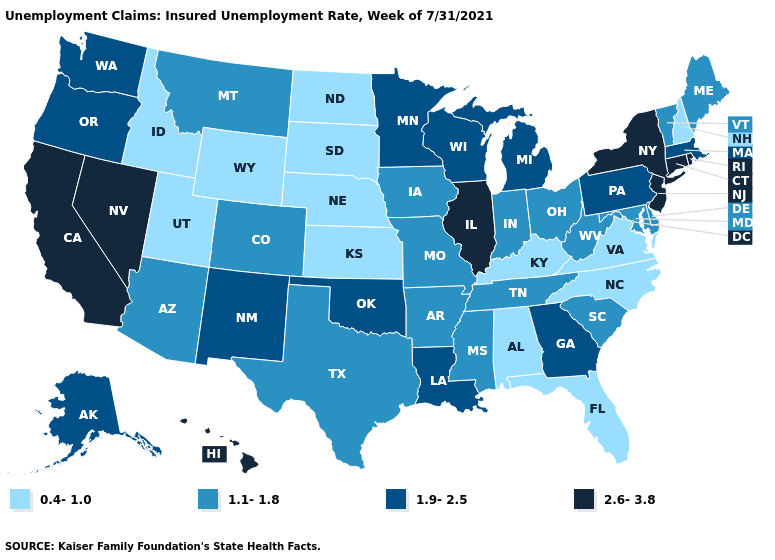What is the value of Alaska?
Concise answer only. 1.9-2.5. Among the states that border Nebraska , does Kansas have the highest value?
Quick response, please. No. Name the states that have a value in the range 2.6-3.8?
Give a very brief answer. California, Connecticut, Hawaii, Illinois, Nevada, New Jersey, New York, Rhode Island. What is the lowest value in the MidWest?
Be succinct. 0.4-1.0. What is the highest value in the USA?
Be succinct. 2.6-3.8. Name the states that have a value in the range 2.6-3.8?
Answer briefly. California, Connecticut, Hawaii, Illinois, Nevada, New Jersey, New York, Rhode Island. Does Wyoming have a lower value than Wisconsin?
Quick response, please. Yes. What is the value of Illinois?
Keep it brief. 2.6-3.8. What is the lowest value in states that border Wisconsin?
Quick response, please. 1.1-1.8. Name the states that have a value in the range 0.4-1.0?
Concise answer only. Alabama, Florida, Idaho, Kansas, Kentucky, Nebraska, New Hampshire, North Carolina, North Dakota, South Dakota, Utah, Virginia, Wyoming. What is the lowest value in states that border Idaho?
Give a very brief answer. 0.4-1.0. What is the lowest value in the USA?
Concise answer only. 0.4-1.0. What is the lowest value in the USA?
Concise answer only. 0.4-1.0. Name the states that have a value in the range 2.6-3.8?
Be succinct. California, Connecticut, Hawaii, Illinois, Nevada, New Jersey, New York, Rhode Island. Name the states that have a value in the range 0.4-1.0?
Give a very brief answer. Alabama, Florida, Idaho, Kansas, Kentucky, Nebraska, New Hampshire, North Carolina, North Dakota, South Dakota, Utah, Virginia, Wyoming. 